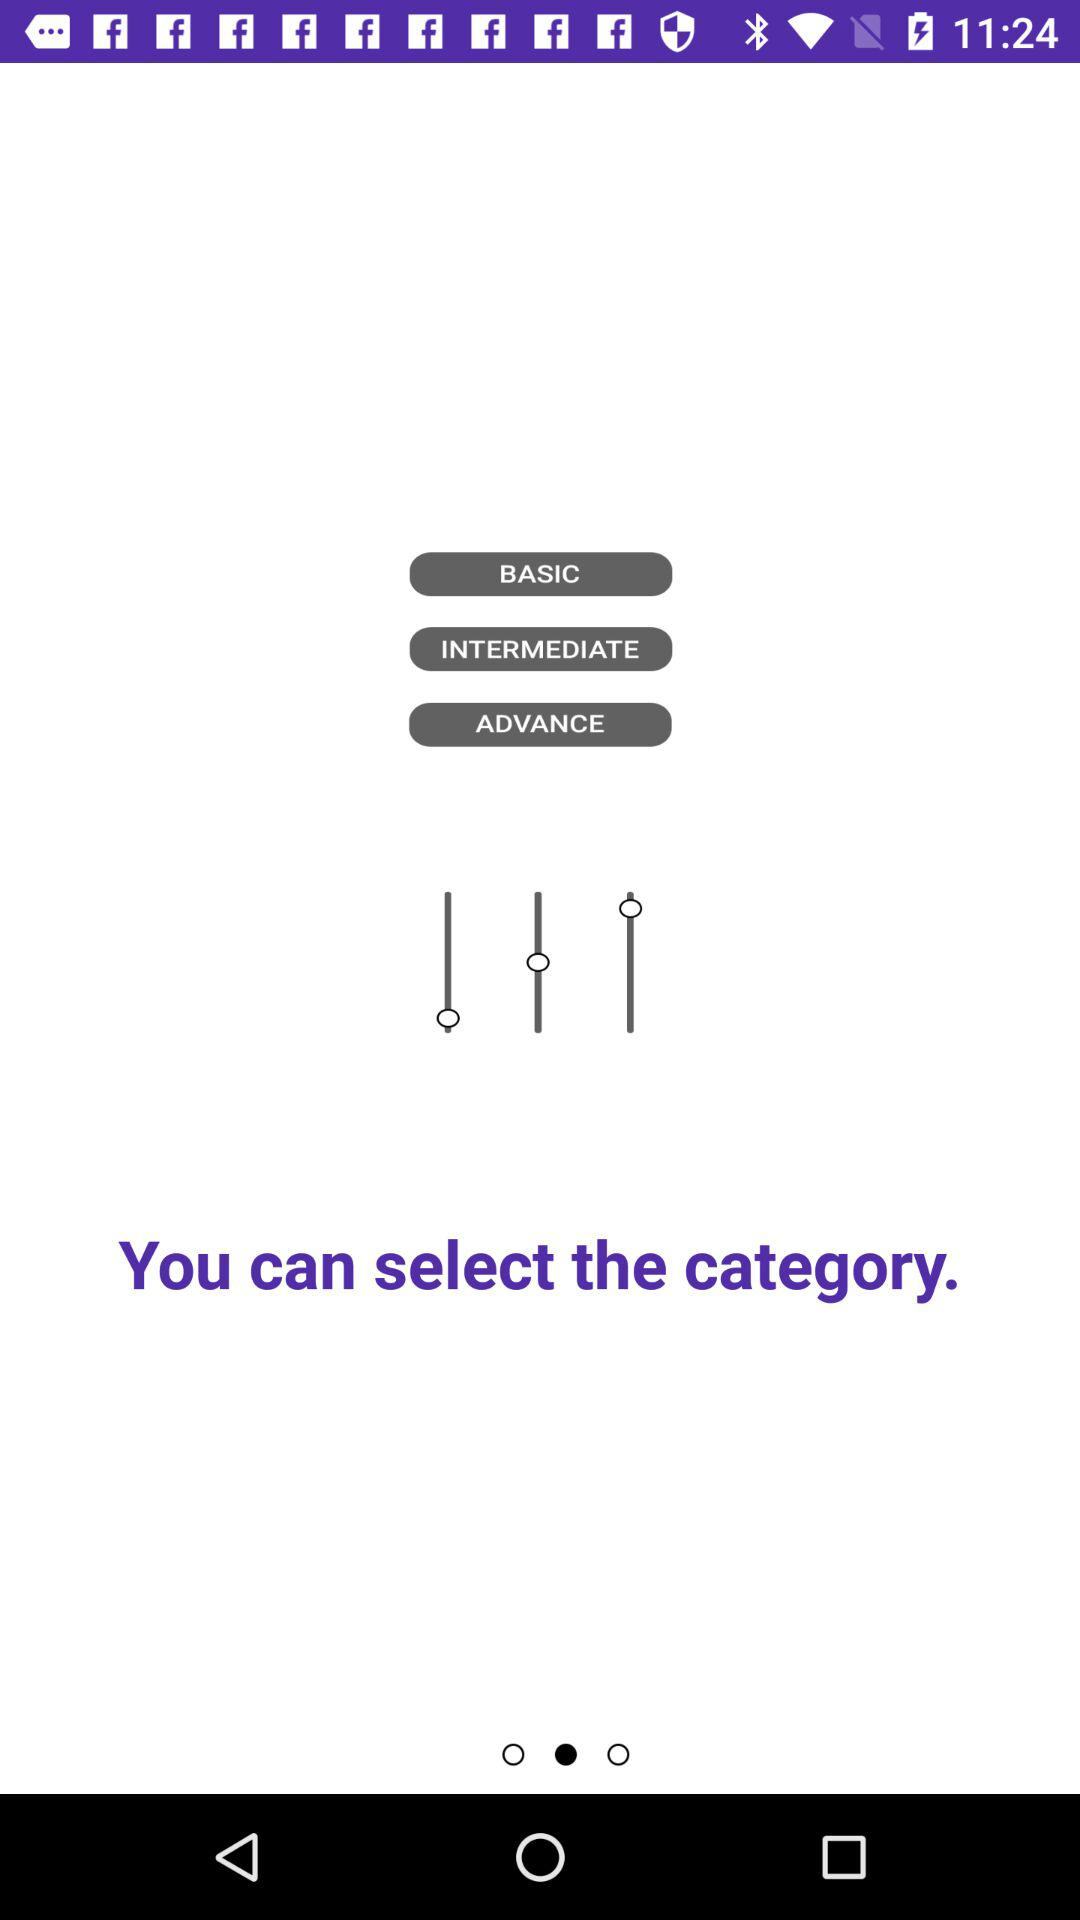Which category is selected?
When the provided information is insufficient, respond with <no answer>. <no answer> 